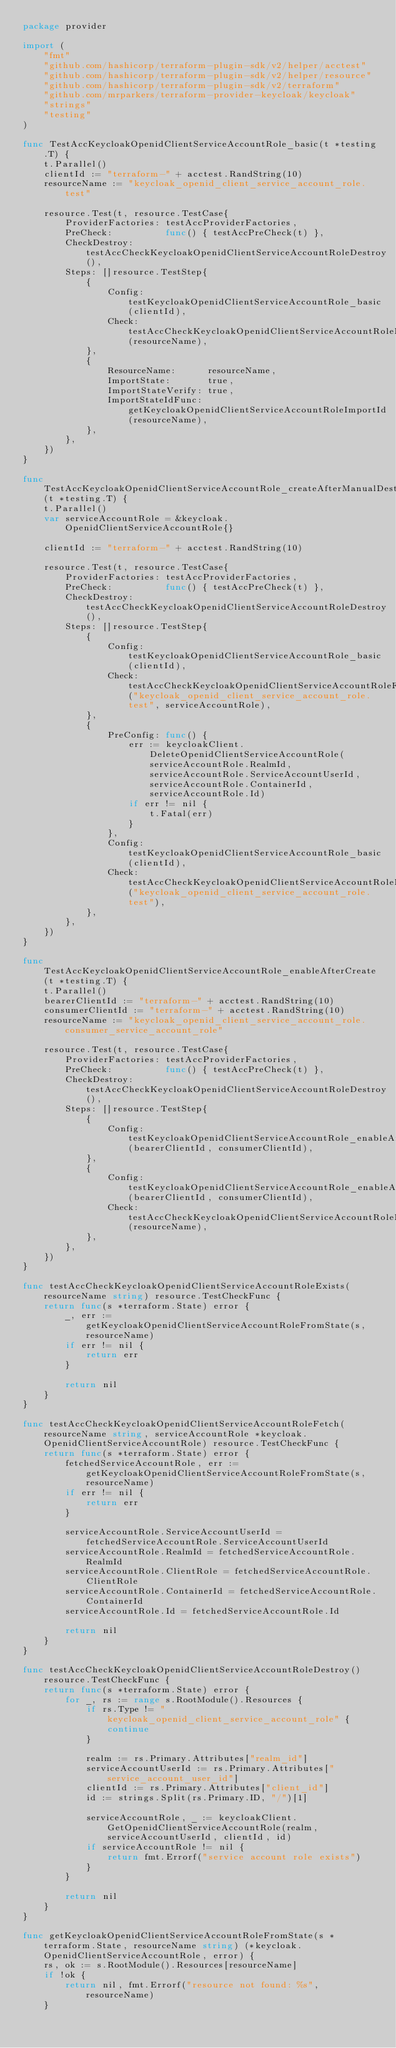Convert code to text. <code><loc_0><loc_0><loc_500><loc_500><_Go_>package provider

import (
	"fmt"
	"github.com/hashicorp/terraform-plugin-sdk/v2/helper/acctest"
	"github.com/hashicorp/terraform-plugin-sdk/v2/helper/resource"
	"github.com/hashicorp/terraform-plugin-sdk/v2/terraform"
	"github.com/mrparkers/terraform-provider-keycloak/keycloak"
	"strings"
	"testing"
)

func TestAccKeycloakOpenidClientServiceAccountRole_basic(t *testing.T) {
	t.Parallel()
	clientId := "terraform-" + acctest.RandString(10)
	resourceName := "keycloak_openid_client_service_account_role.test"

	resource.Test(t, resource.TestCase{
		ProviderFactories: testAccProviderFactories,
		PreCheck:          func() { testAccPreCheck(t) },
		CheckDestroy:      testAccCheckKeycloakOpenidClientServiceAccountRoleDestroy(),
		Steps: []resource.TestStep{
			{
				Config: testKeycloakOpenidClientServiceAccountRole_basic(clientId),
				Check:  testAccCheckKeycloakOpenidClientServiceAccountRoleExists(resourceName),
			},
			{
				ResourceName:      resourceName,
				ImportState:       true,
				ImportStateVerify: true,
				ImportStateIdFunc: getKeycloakOpenidClientServiceAccountRoleImportId(resourceName),
			},
		},
	})
}

func TestAccKeycloakOpenidClientServiceAccountRole_createAfterManualDestroy(t *testing.T) {
	t.Parallel()
	var serviceAccountRole = &keycloak.OpenidClientServiceAccountRole{}

	clientId := "terraform-" + acctest.RandString(10)

	resource.Test(t, resource.TestCase{
		ProviderFactories: testAccProviderFactories,
		PreCheck:          func() { testAccPreCheck(t) },
		CheckDestroy:      testAccCheckKeycloakOpenidClientServiceAccountRoleDestroy(),
		Steps: []resource.TestStep{
			{
				Config: testKeycloakOpenidClientServiceAccountRole_basic(clientId),
				Check:  testAccCheckKeycloakOpenidClientServiceAccountRoleFetch("keycloak_openid_client_service_account_role.test", serviceAccountRole),
			},
			{
				PreConfig: func() {
					err := keycloakClient.DeleteOpenidClientServiceAccountRole(serviceAccountRole.RealmId, serviceAccountRole.ServiceAccountUserId, serviceAccountRole.ContainerId, serviceAccountRole.Id)
					if err != nil {
						t.Fatal(err)
					}
				},
				Config: testKeycloakOpenidClientServiceAccountRole_basic(clientId),
				Check:  testAccCheckKeycloakOpenidClientServiceAccountRoleExists("keycloak_openid_client_service_account_role.test"),
			},
		},
	})
}

func TestAccKeycloakOpenidClientServiceAccountRole_enableAfterCreate(t *testing.T) {
	t.Parallel()
	bearerClientId := "terraform-" + acctest.RandString(10)
	consumerClientId := "terraform-" + acctest.RandString(10)
	resourceName := "keycloak_openid_client_service_account_role.consumer_service_account_role"

	resource.Test(t, resource.TestCase{
		ProviderFactories: testAccProviderFactories,
		PreCheck:          func() { testAccPreCheck(t) },
		CheckDestroy:      testAccCheckKeycloakOpenidClientServiceAccountRoleDestroy(),
		Steps: []resource.TestStep{
			{
				Config: testKeycloakOpenidClientServiceAccountRole_enableAfterCreate_before(bearerClientId, consumerClientId),
			},
			{
				Config: testKeycloakOpenidClientServiceAccountRole_enableAfterCreate_after(bearerClientId, consumerClientId),
				Check:  testAccCheckKeycloakOpenidClientServiceAccountRoleExists(resourceName),
			},
		},
	})
}

func testAccCheckKeycloakOpenidClientServiceAccountRoleExists(resourceName string) resource.TestCheckFunc {
	return func(s *terraform.State) error {
		_, err := getKeycloakOpenidClientServiceAccountRoleFromState(s, resourceName)
		if err != nil {
			return err
		}

		return nil
	}
}

func testAccCheckKeycloakOpenidClientServiceAccountRoleFetch(resourceName string, serviceAccountRole *keycloak.OpenidClientServiceAccountRole) resource.TestCheckFunc {
	return func(s *terraform.State) error {
		fetchedServiceAccountRole, err := getKeycloakOpenidClientServiceAccountRoleFromState(s, resourceName)
		if err != nil {
			return err
		}

		serviceAccountRole.ServiceAccountUserId = fetchedServiceAccountRole.ServiceAccountUserId
		serviceAccountRole.RealmId = fetchedServiceAccountRole.RealmId
		serviceAccountRole.ClientRole = fetchedServiceAccountRole.ClientRole
		serviceAccountRole.ContainerId = fetchedServiceAccountRole.ContainerId
		serviceAccountRole.Id = fetchedServiceAccountRole.Id

		return nil
	}
}

func testAccCheckKeycloakOpenidClientServiceAccountRoleDestroy() resource.TestCheckFunc {
	return func(s *terraform.State) error {
		for _, rs := range s.RootModule().Resources {
			if rs.Type != "keycloak_openid_client_service_account_role" {
				continue
			}

			realm := rs.Primary.Attributes["realm_id"]
			serviceAccountUserId := rs.Primary.Attributes["service_account_user_id"]
			clientId := rs.Primary.Attributes["client_id"]
			id := strings.Split(rs.Primary.ID, "/")[1]

			serviceAccountRole, _ := keycloakClient.GetOpenidClientServiceAccountRole(realm, serviceAccountUserId, clientId, id)
			if serviceAccountRole != nil {
				return fmt.Errorf("service account role exists")
			}
		}

		return nil
	}
}

func getKeycloakOpenidClientServiceAccountRoleFromState(s *terraform.State, resourceName string) (*keycloak.OpenidClientServiceAccountRole, error) {
	rs, ok := s.RootModule().Resources[resourceName]
	if !ok {
		return nil, fmt.Errorf("resource not found: %s", resourceName)
	}
</code> 